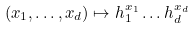<formula> <loc_0><loc_0><loc_500><loc_500>( x _ { 1 } , \dots , x _ { d } ) \mapsto h _ { 1 } ^ { x _ { 1 } } \dots h _ { d } ^ { x _ { d } }</formula> 